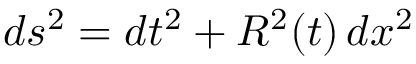Convert formula to latex. <formula><loc_0><loc_0><loc_500><loc_500>d s ^ { 2 } = d t ^ { 2 } + R ^ { 2 } ( t ) \, d x ^ { 2 }</formula> 